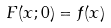<formula> <loc_0><loc_0><loc_500><loc_500>F ( x ; 0 ) = f ( x )</formula> 